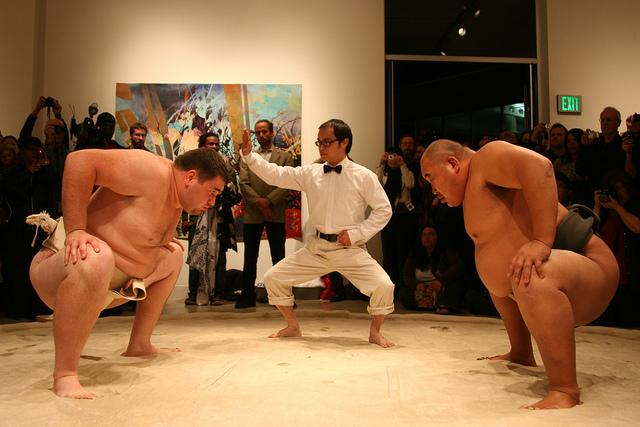This activity is most associated with which people group?

Choices:
A) tibetans
B) tanzanians
C) japanese
D) inuit japanese 